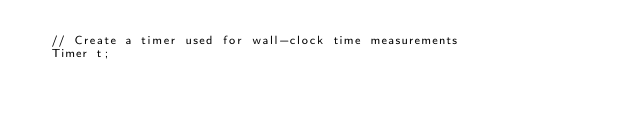Convert code to text. <code><loc_0><loc_0><loc_500><loc_500><_C++_>  // Create a timer used for wall-clock time measurements
  Timer t;
</code> 